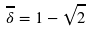Convert formula to latex. <formula><loc_0><loc_0><loc_500><loc_500>\overline { \delta } = 1 - \sqrt { 2 }</formula> 